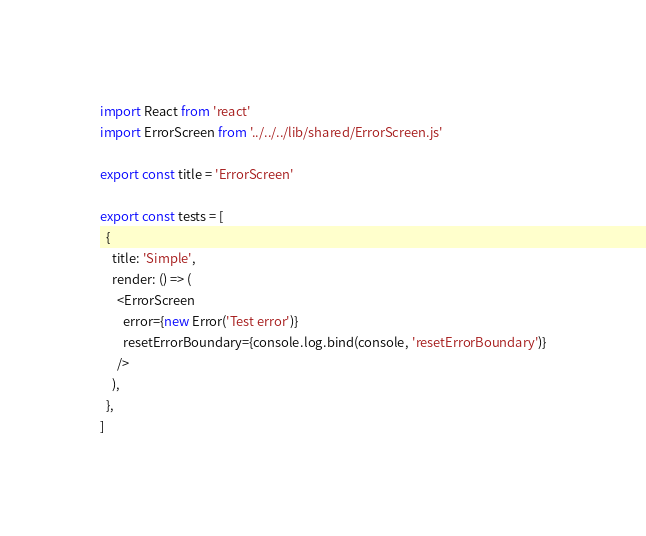<code> <loc_0><loc_0><loc_500><loc_500><_JavaScript_>import React from 'react'
import ErrorScreen from '../../../lib/shared/ErrorScreen.js'

export const title = 'ErrorScreen'

export const tests = [
  {
    title: 'Simple',
    render: () => (
      <ErrorScreen
        error={new Error('Test error')}
        resetErrorBoundary={console.log.bind(console, 'resetErrorBoundary')}
      />
    ),
  },
]
</code> 